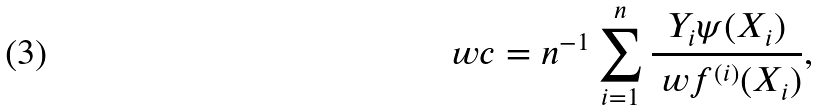Convert formula to latex. <formula><loc_0><loc_0><loc_500><loc_500>\ w c = n ^ { - 1 } \sum _ { i = 1 } ^ { n } \frac { Y _ { i } \psi ( X _ { i } ) } { \ w f ^ { ( i ) } ( X _ { i } ) } ,</formula> 